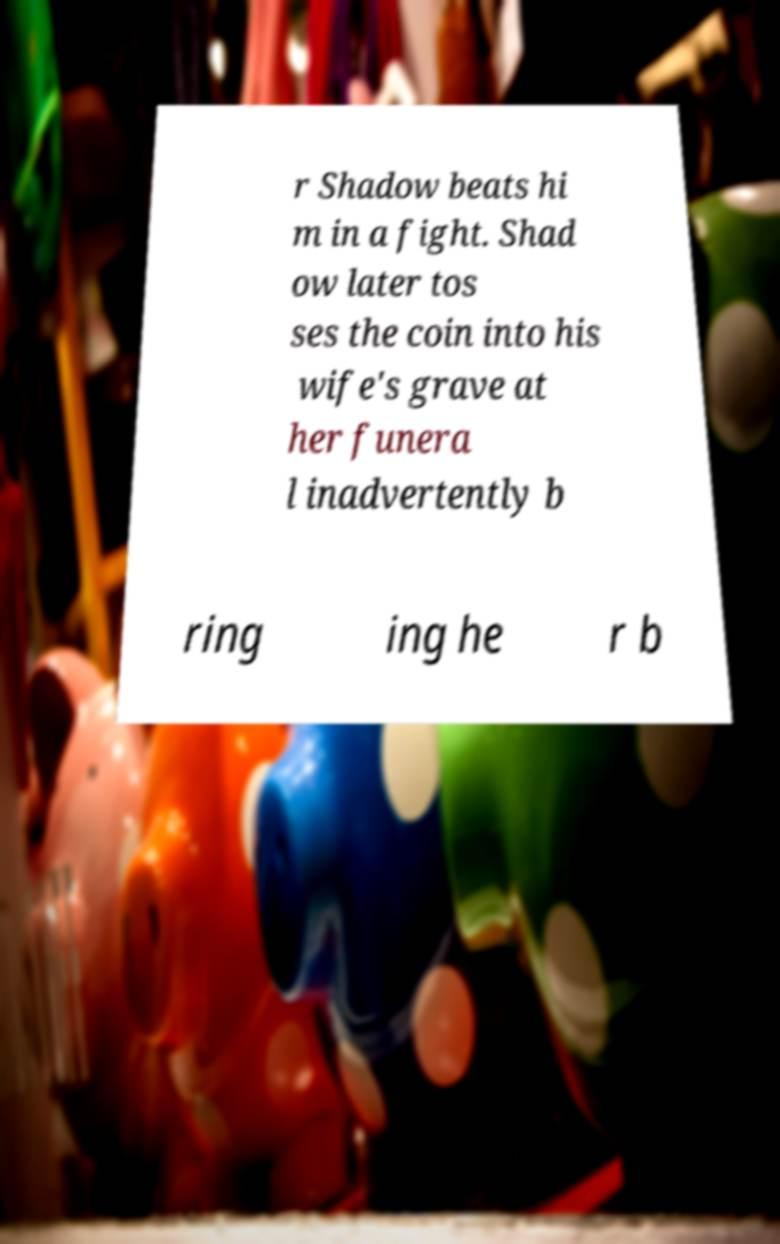I need the written content from this picture converted into text. Can you do that? r Shadow beats hi m in a fight. Shad ow later tos ses the coin into his wife's grave at her funera l inadvertently b ring ing he r b 